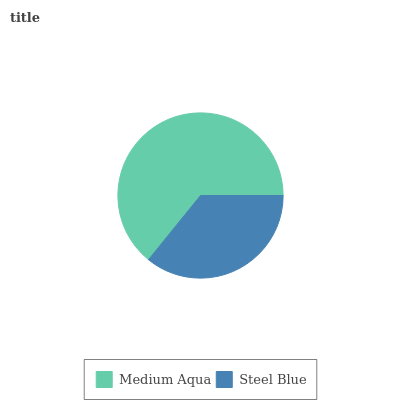Is Steel Blue the minimum?
Answer yes or no. Yes. Is Medium Aqua the maximum?
Answer yes or no. Yes. Is Steel Blue the maximum?
Answer yes or no. No. Is Medium Aqua greater than Steel Blue?
Answer yes or no. Yes. Is Steel Blue less than Medium Aqua?
Answer yes or no. Yes. Is Steel Blue greater than Medium Aqua?
Answer yes or no. No. Is Medium Aqua less than Steel Blue?
Answer yes or no. No. Is Medium Aqua the high median?
Answer yes or no. Yes. Is Steel Blue the low median?
Answer yes or no. Yes. Is Steel Blue the high median?
Answer yes or no. No. Is Medium Aqua the low median?
Answer yes or no. No. 